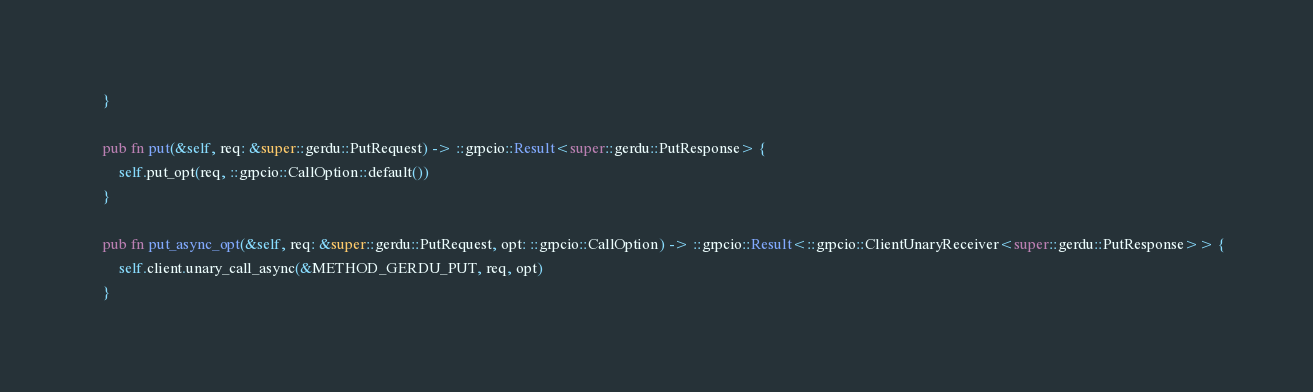Convert code to text. <code><loc_0><loc_0><loc_500><loc_500><_Rust_>    }

    pub fn put(&self, req: &super::gerdu::PutRequest) -> ::grpcio::Result<super::gerdu::PutResponse> {
        self.put_opt(req, ::grpcio::CallOption::default())
    }

    pub fn put_async_opt(&self, req: &super::gerdu::PutRequest, opt: ::grpcio::CallOption) -> ::grpcio::Result<::grpcio::ClientUnaryReceiver<super::gerdu::PutResponse>> {
        self.client.unary_call_async(&METHOD_GERDU_PUT, req, opt)
    }
</code> 